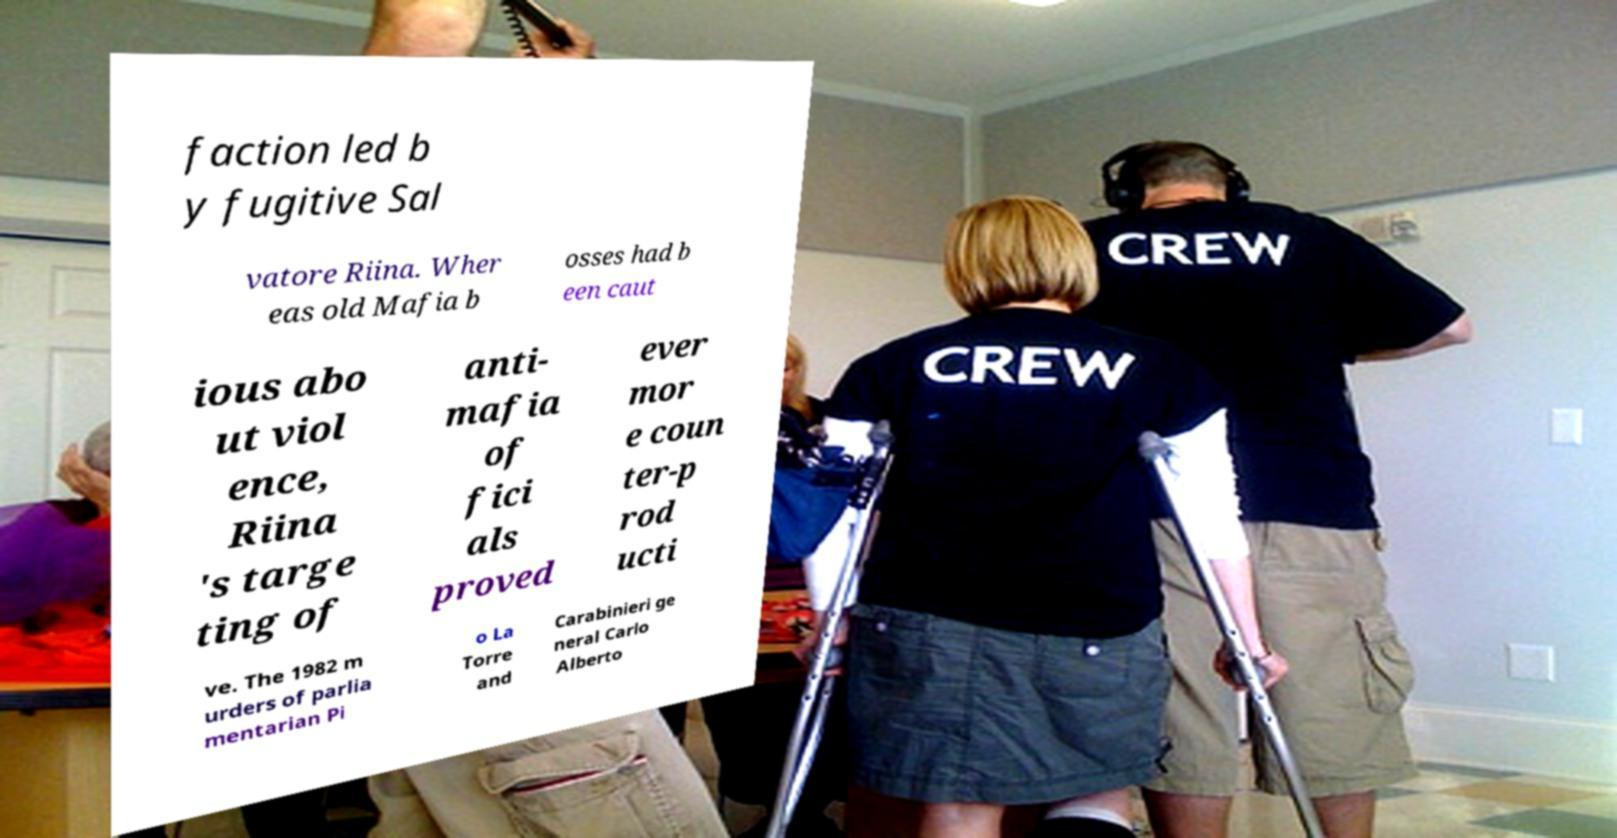What messages or text are displayed in this image? I need them in a readable, typed format. faction led b y fugitive Sal vatore Riina. Wher eas old Mafia b osses had b een caut ious abo ut viol ence, Riina 's targe ting of anti- mafia of fici als proved ever mor e coun ter-p rod ucti ve. The 1982 m urders of parlia mentarian Pi o La Torre and Carabinieri ge neral Carlo Alberto 